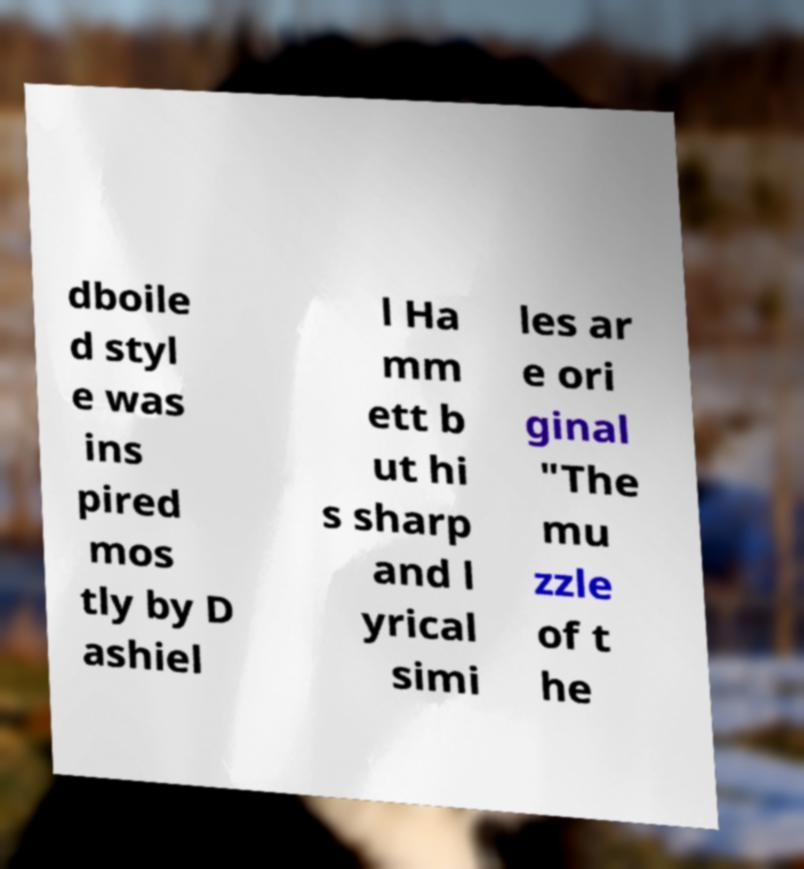There's text embedded in this image that I need extracted. Can you transcribe it verbatim? dboile d styl e was ins pired mos tly by D ashiel l Ha mm ett b ut hi s sharp and l yrical simi les ar e ori ginal "The mu zzle of t he 